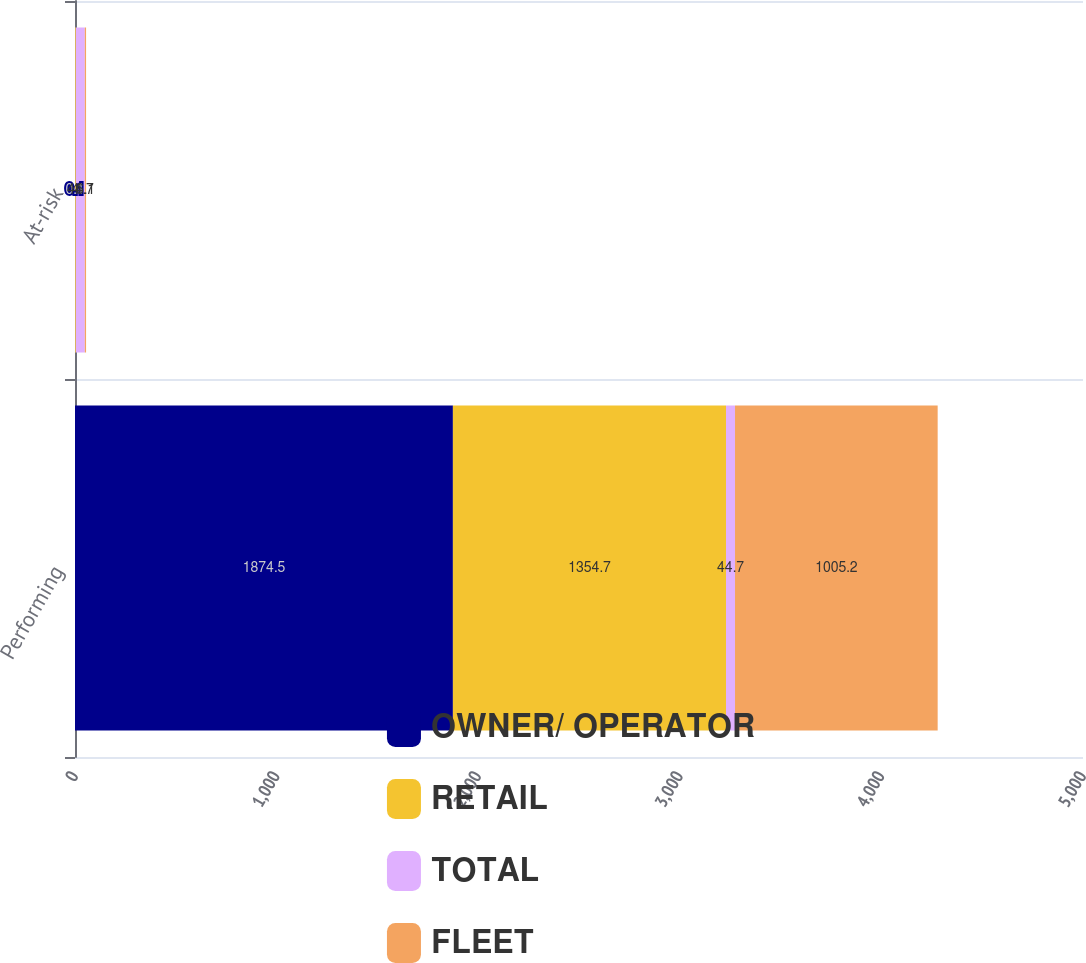Convert chart to OTSL. <chart><loc_0><loc_0><loc_500><loc_500><stacked_bar_chart><ecel><fcel>Performing<fcel>At-risk<nl><fcel>OWNER/ OPERATOR<fcel>1874.5<fcel>0.1<nl><fcel>RETAIL<fcel>1354.7<fcel>4<nl><fcel>TOTAL<fcel>44.7<fcel>44.7<nl><fcel>FLEET<fcel>1005.2<fcel>6.1<nl></chart> 